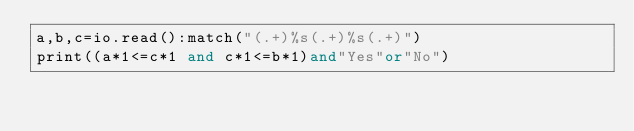<code> <loc_0><loc_0><loc_500><loc_500><_Lua_>a,b,c=io.read():match("(.+)%s(.+)%s(.+)")
print((a*1<=c*1 and c*1<=b*1)and"Yes"or"No")</code> 